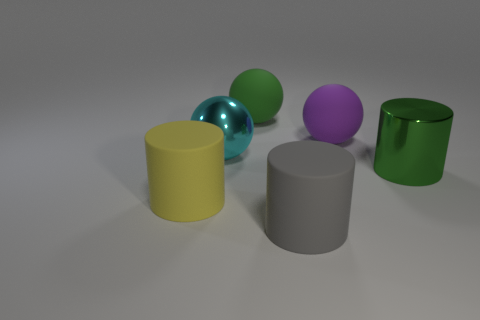Is the shape of the green metallic object the same as the gray rubber thing?
Provide a short and direct response. Yes. What number of gray objects are in front of the matte cylinder that is to the right of the large cyan thing?
Give a very brief answer. 0. The big gray object that is made of the same material as the yellow thing is what shape?
Your response must be concise. Cylinder. What number of green objects are metallic balls or metallic things?
Your response must be concise. 1. Is there a large green sphere in front of the green thing that is to the right of the large matte ball right of the big gray cylinder?
Offer a very short reply. No. Is the number of large metal spheres less than the number of large rubber spheres?
Your answer should be very brief. Yes. Is the shape of the green thing that is in front of the green rubber sphere the same as  the large yellow matte thing?
Provide a succinct answer. Yes. Are any red shiny objects visible?
Keep it short and to the point. No. There is a metallic thing that is in front of the metallic thing that is left of the metal object that is right of the purple object; what color is it?
Keep it short and to the point. Green. Are there an equal number of cyan metal objects that are in front of the big yellow cylinder and metal balls that are in front of the big gray cylinder?
Make the answer very short. Yes. 